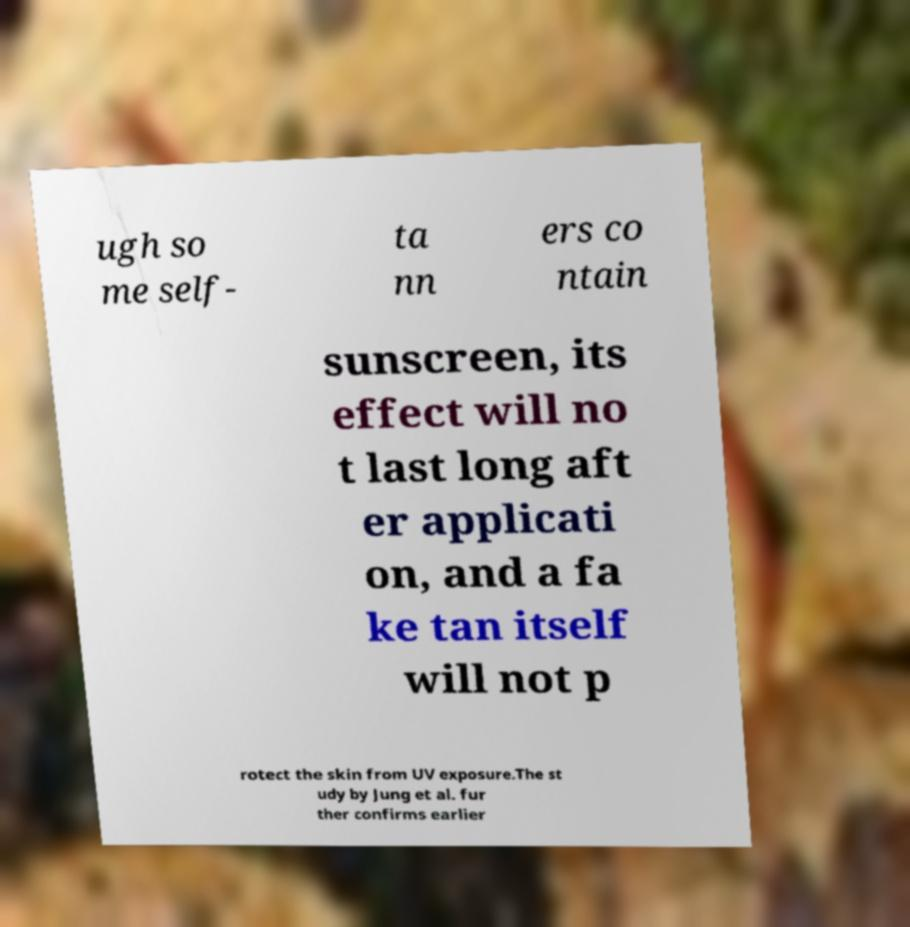For documentation purposes, I need the text within this image transcribed. Could you provide that? ugh so me self- ta nn ers co ntain sunscreen, its effect will no t last long aft er applicati on, and a fa ke tan itself will not p rotect the skin from UV exposure.The st udy by Jung et al. fur ther confirms earlier 